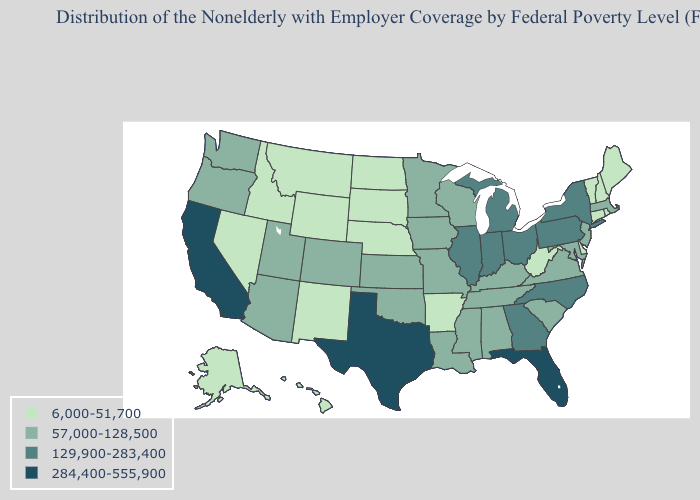Name the states that have a value in the range 129,900-283,400?
Be succinct. Georgia, Illinois, Indiana, Michigan, New York, North Carolina, Ohio, Pennsylvania. Name the states that have a value in the range 129,900-283,400?
Short answer required. Georgia, Illinois, Indiana, Michigan, New York, North Carolina, Ohio, Pennsylvania. Which states hav the highest value in the South?
Answer briefly. Florida, Texas. Is the legend a continuous bar?
Give a very brief answer. No. What is the value of Tennessee?
Write a very short answer. 57,000-128,500. Name the states that have a value in the range 284,400-555,900?
Short answer required. California, Florida, Texas. What is the highest value in the USA?
Quick response, please. 284,400-555,900. What is the lowest value in the USA?
Write a very short answer. 6,000-51,700. Among the states that border Arkansas , which have the highest value?
Give a very brief answer. Texas. Does Kentucky have the lowest value in the South?
Be succinct. No. Does the map have missing data?
Quick response, please. No. Name the states that have a value in the range 57,000-128,500?
Quick response, please. Alabama, Arizona, Colorado, Iowa, Kansas, Kentucky, Louisiana, Maryland, Massachusetts, Minnesota, Mississippi, Missouri, New Jersey, Oklahoma, Oregon, South Carolina, Tennessee, Utah, Virginia, Washington, Wisconsin. What is the value of Virginia?
Give a very brief answer. 57,000-128,500. Does the map have missing data?
Answer briefly. No. What is the highest value in states that border Florida?
Quick response, please. 129,900-283,400. 